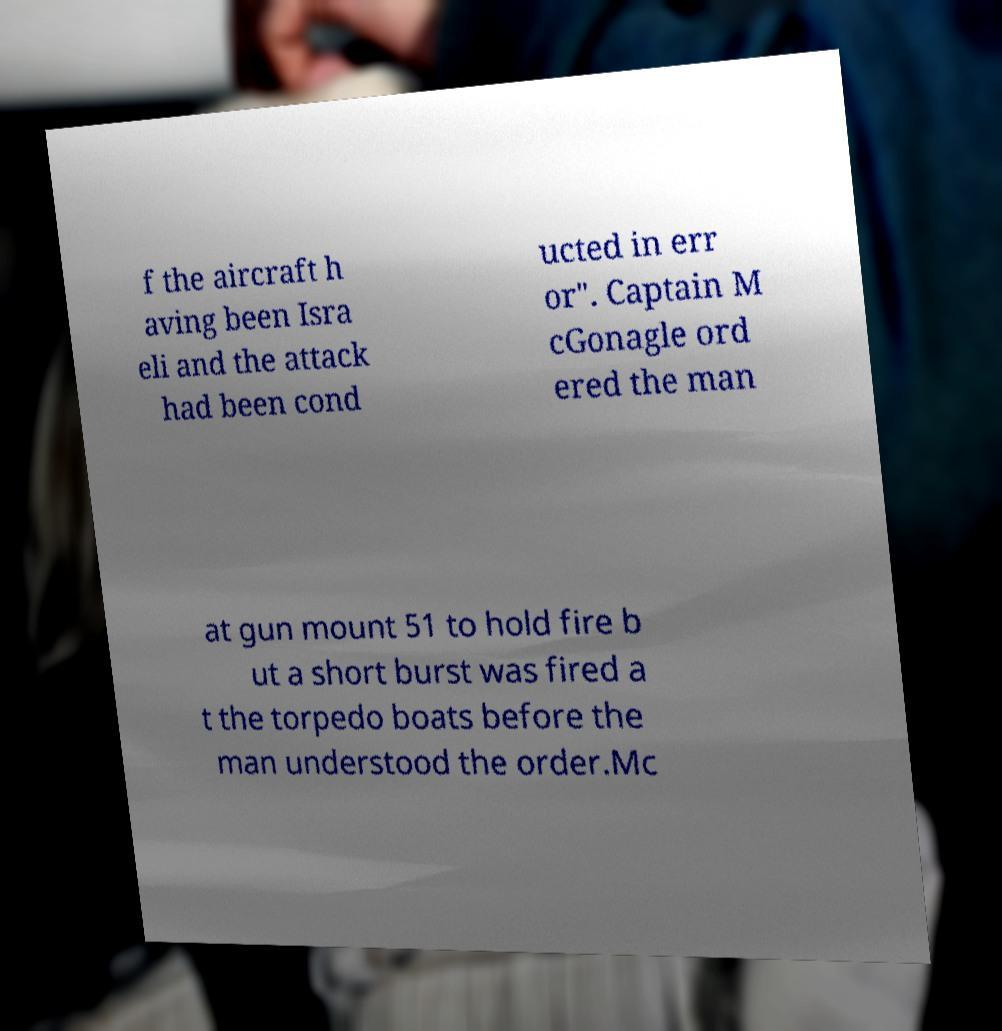I need the written content from this picture converted into text. Can you do that? f the aircraft h aving been Isra eli and the attack had been cond ucted in err or". Captain M cGonagle ord ered the man at gun mount 51 to hold fire b ut a short burst was fired a t the torpedo boats before the man understood the order.Mc 